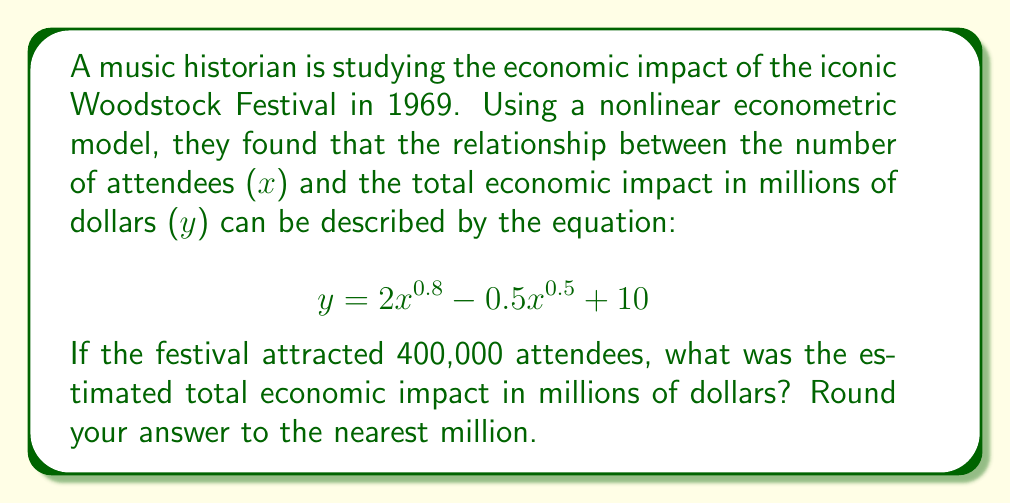What is the answer to this math problem? To solve this problem, we need to follow these steps:

1. Identify the given information:
   - The nonlinear econometric model: $y = 2x^{0.8} - 0.5x^{0.5} + 10$
   - Number of attendees (x): 400,000

2. Substitute x = 400,000 into the equation:
   $$ y = 2(400,000)^{0.8} - 0.5(400,000)^{0.5} + 10 $$

3. Calculate each term:
   a) $2(400,000)^{0.8}$:
      $400,000^{0.8} = 63,095.7344$
      $2 * 63,095.7344 = 126,191.4688$

   b) $0.5(400,000)^{0.5}$:
      $400,000^{0.5} = 632.4555$
      $0.5 * 632.4555 = 316.2278$

   c) The constant term is 10

4. Combine the terms:
   $$ y = 126,191.4688 - 316.2278 + 10 = 125,885.2410 $$

5. Round to the nearest million:
   125,885.2410 rounds to 126 million dollars
Answer: $126 million 